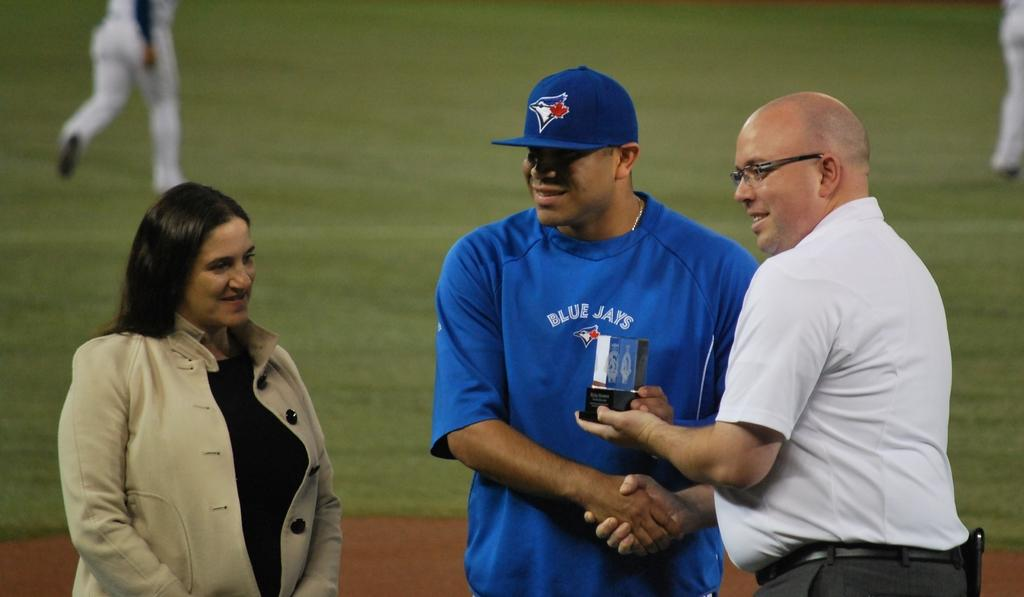Provide a one-sentence caption for the provided image. A baseball player with Blue Jays jersey stands between two people. 